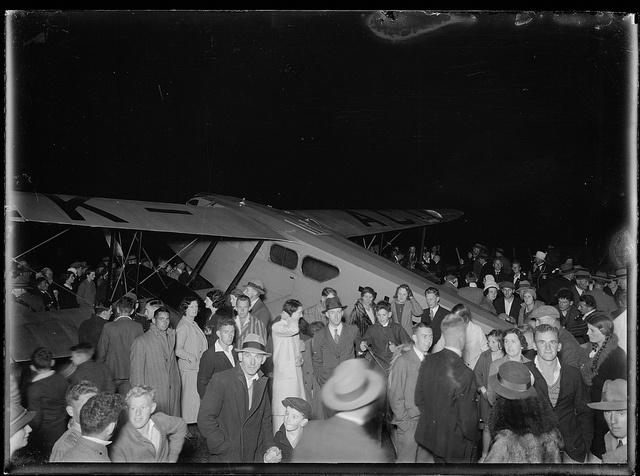Describe the objects in this image and their specific colors. I can see people in black, gray, darkgray, and lightgray tones, airplane in black, gray, and lightgray tones, people in black, gray, darkgray, and lightgray tones, people in black, gray, darkgray, and lightgray tones, and people in black, darkgray, gray, and lightgray tones in this image. 